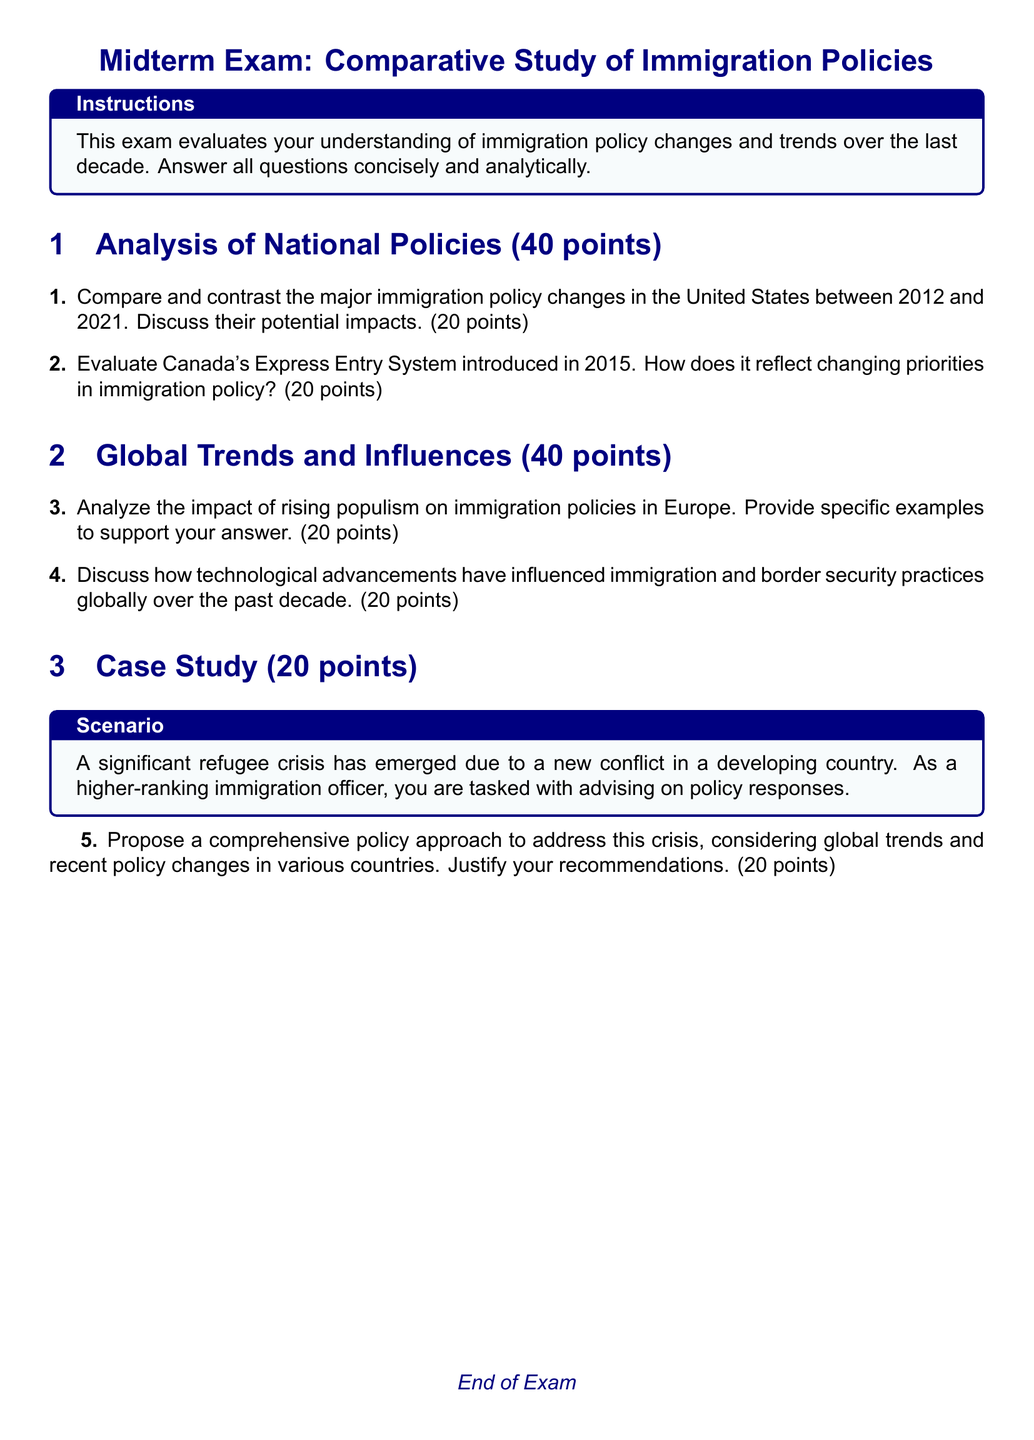What is the total number of sections in the exam? The document has three main sections: Analysis of National Policies, Global Trends and Influences, and Case Study.
Answer: 3 What is the point distribution for the analysis of national policies section? The Analysis of National Policies section totals 40 points, divided into two questions, each worth 20 points.
Answer: 40 points What year was Canada's Express Entry System introduced? The document specifies the introduction of Canada's Express Entry System in the year 2015.
Answer: 2015 What is the maximum number of points for the case study question? The case study question is assigned a total of 20 points in the exam structure.
Answer: 20 points What is the color theme used in the document? The document uses navy for text and headings, with a light blue background for certain sections like instructions and scenarios.
Answer: Navy and light blue Name one global trend mentioned that has influenced immigration policies. The document mentions rising populism as a major global trend influencing immigration policies in Europe.
Answer: Rising populism How many total points can be earned on the midterm exam? The total points are the sum of points from all sections: 40 + 40 + 20, which totals to 100 points.
Answer: 100 points What document type is this? The document is specifically a midterm exam format catered towards immigration policies and their comparative study.
Answer: Midterm exam 